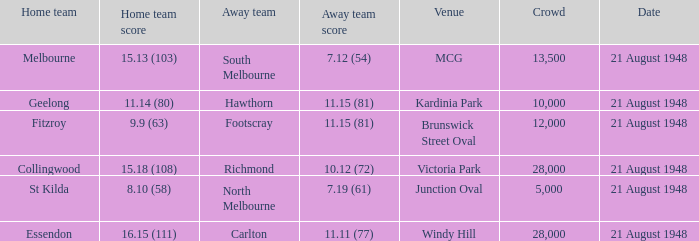When the venue is victoria park, what's the largest Crowd that attended? 28000.0. 